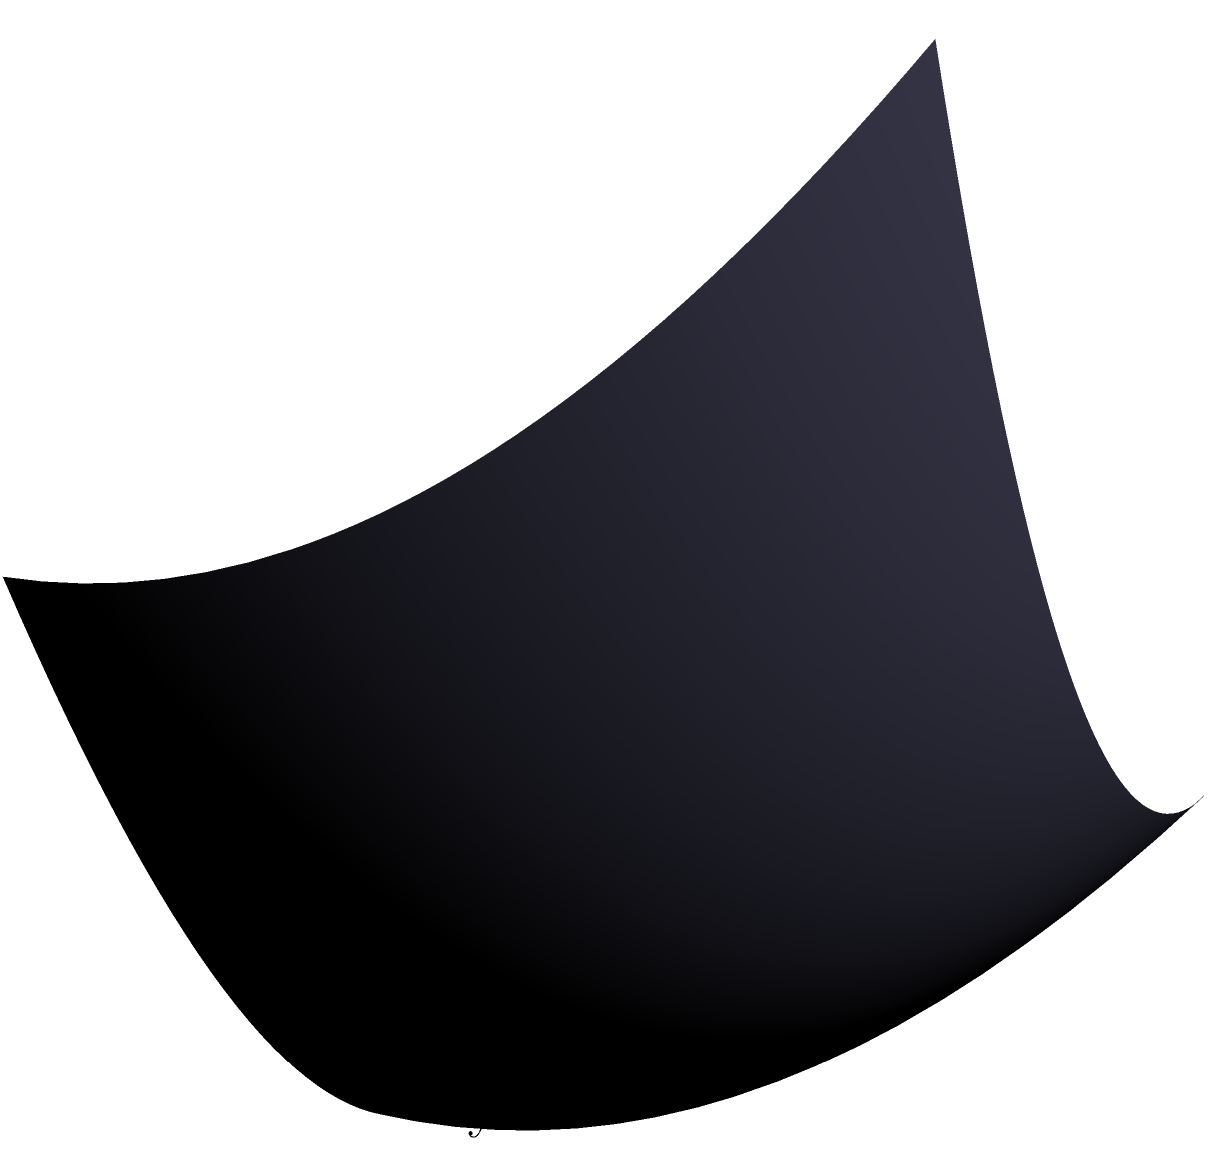As a pediatrician specializing in infant nutrition, you're analyzing a 3D growth chart for twin infants. The chart shows weight gain (z-axis) as a function of age (x-axis) and nutrient intake (y-axis). Two projections, A (red) and B (green), are shown on the YZ and XZ planes respectively. If you were to rotate the 3D model 90 degrees clockwise around the z-axis, which projection would now appear on the XZ plane? Let's approach this step-by-step:

1. First, let's understand what we're looking at:
   - The 3D surface represents weight gain as a function of age and nutrient intake.
   - Projection A (red) is currently on the YZ plane.
   - Projection B (green) is currently on the XZ plane.

2. Now, let's visualize a 90-degree clockwise rotation around the z-axis:
   - This rotation will swap the x and y axes.
   - The positive x-axis will become the negative y-axis.
   - The positive y-axis will become the positive x-axis.

3. After this rotation:
   - What was originally on the YZ plane will now be on the XZ plane.
   - What was originally on the XZ plane will now be on the YZ plane.

4. Therefore:
   - Projection A, which was originally on the YZ plane, will now appear on the XZ plane.
   - Projection B, which was originally on the XZ plane, will now appear on the YZ plane.

5. This rotation effectively swaps the positions of the two projections relative to the axes.
Answer: A 